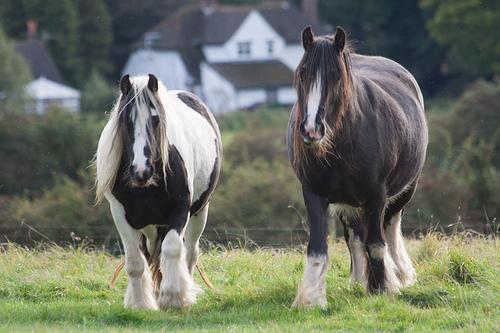How many horses are there?
Give a very brief answer. 2. 